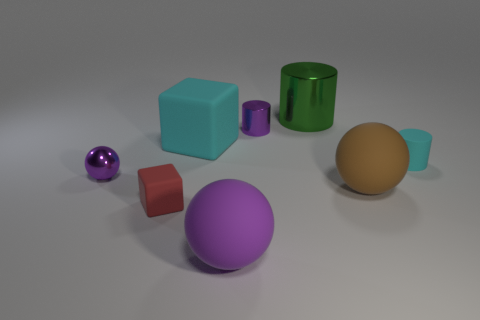Is the number of cyan matte objects that are to the right of the big metallic cylinder less than the number of matte things on the right side of the big purple sphere?
Make the answer very short. Yes. The small purple object to the right of the cyan cube that is to the left of the tiny metal cylinder is what shape?
Make the answer very short. Cylinder. How many other things are the same material as the cyan block?
Keep it short and to the point. 4. Are there more big brown balls than tiny purple objects?
Make the answer very short. No. How big is the block in front of the purple object left of the cube that is behind the small red rubber block?
Your response must be concise. Small. Do the purple cylinder and the cyan thing that is on the left side of the green object have the same size?
Ensure brevity in your answer.  No. Is the number of small cylinders that are in front of the tiny matte cylinder less than the number of green metal things?
Give a very brief answer. Yes. How many matte spheres are the same color as the metallic sphere?
Your answer should be very brief. 1. Are there fewer large cyan cubes than spheres?
Make the answer very short. Yes. Are the big purple sphere and the large cyan block made of the same material?
Make the answer very short. Yes. 